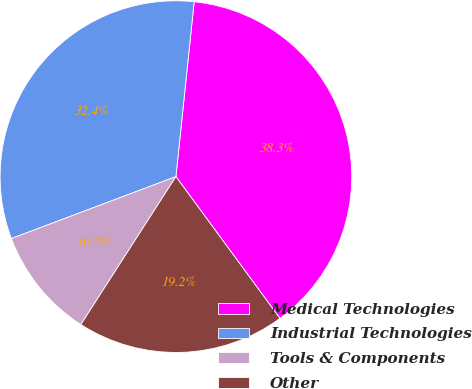Convert chart. <chart><loc_0><loc_0><loc_500><loc_500><pie_chart><fcel>Medical Technologies<fcel>Industrial Technologies<fcel>Tools & Components<fcel>Other<nl><fcel>38.27%<fcel>32.38%<fcel>10.18%<fcel>19.16%<nl></chart> 